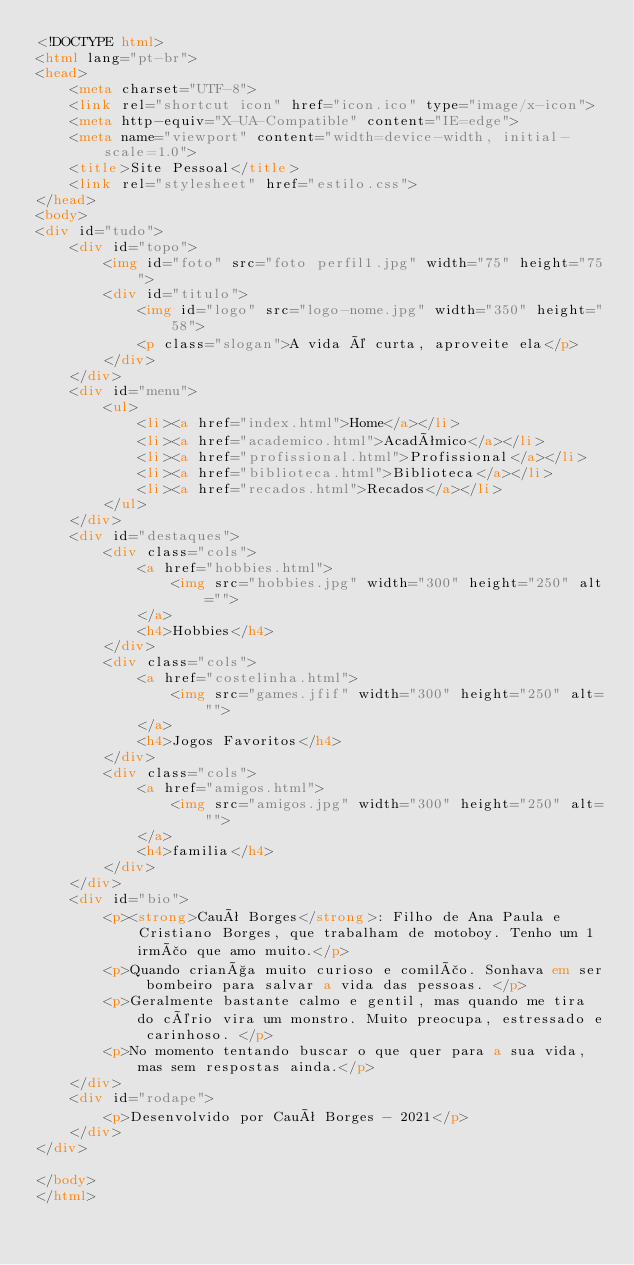Convert code to text. <code><loc_0><loc_0><loc_500><loc_500><_HTML_><!DOCTYPE html>
<html lang="pt-br">
<head>
    <meta charset="UTF-8">
    <link rel="shortcut icon" href="icon.ico" type="image/x-icon">
    <meta http-equiv="X-UA-Compatible" content="IE=edge">
    <meta name="viewport" content="width=device-width, initial-scale=1.0">
    <title>Site Pessoal</title>
    <link rel="stylesheet" href="estilo.css">
</head>
<body>
<div id="tudo">
    <div id="topo">
        <img id="foto" src="foto perfil1.jpg" width="75" height="75">
        <div id="titulo">
            <img id="logo" src="logo-nome.jpg" width="350" height="58">
			<p class="slogan">A vida é curta, aproveite ela</p>
		</div>	
    </div>
    <div id="menu">
        <ul>
            <li><a href="index.html">Home</a></li>
            <li><a href="academico.html">Acadêmico</a></li>
            <li><a href="profissional.html">Profissional</a></li>
            <li><a href="biblioteca.html">Biblioteca</a></li>
            <li><a href="recados.html">Recados</a></li>
        </ul>
    </div>
    <div id="destaques">   
        <div class="cols">
            <a href="hobbies.html">
                <img src="hobbies.jpg" width="300" height="250" alt="">
            </a>			
            <h4>Hobbies</h4>
        </div>
        <div class="cols">
            <a href="costelinha.html">
                <img src="games.jfif" width="300" height="250" alt="">
            </a>
            <h4>Jogos Favoritos</h4>			
        </div>
        <div class="cols">
            <a href="amigos.html">
                <img src="amigos.jpg" width="300" height="250" alt="">
            </a>
            <h4>familia</h4>
        </div>      
    </div>
    <div id="bio">
        <p><strong>Cauê Borges</strong>: Filho de Ana Paula e Cristiano Borges, que trabalham de motoboy. Tenho um 1 irmão que amo muito.</p>
        <p>Quando criança muito curioso e comilão. Sonhava em ser bombeiro para salvar a vida das pessoas. </p>
        <p>Geralmente bastante calmo e gentil, mas quando me tira do cério vira um monstro. Muito preocupa, estressado e carinhoso. </p>
        <p>No momento tentando buscar o que quer para a sua vida, mas sem respostas ainda.</p>
    </div>
    <div id="rodape">
        <p>Desenvolvido por Cauê Borges - 2021</p>
    </div>
</div>

</body>
</html></code> 